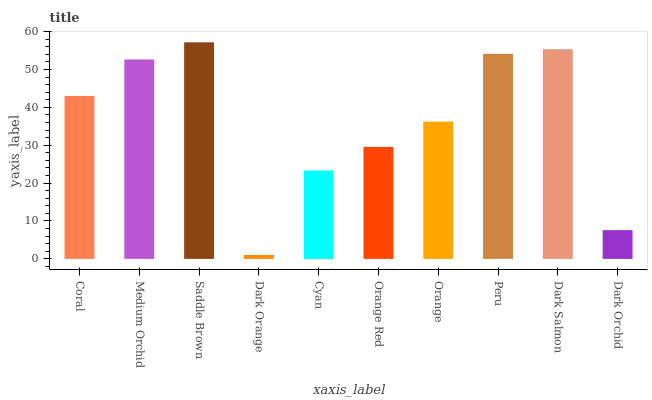Is Dark Orange the minimum?
Answer yes or no. Yes. Is Saddle Brown the maximum?
Answer yes or no. Yes. Is Medium Orchid the minimum?
Answer yes or no. No. Is Medium Orchid the maximum?
Answer yes or no. No. Is Medium Orchid greater than Coral?
Answer yes or no. Yes. Is Coral less than Medium Orchid?
Answer yes or no. Yes. Is Coral greater than Medium Orchid?
Answer yes or no. No. Is Medium Orchid less than Coral?
Answer yes or no. No. Is Coral the high median?
Answer yes or no. Yes. Is Orange the low median?
Answer yes or no. Yes. Is Dark Salmon the high median?
Answer yes or no. No. Is Peru the low median?
Answer yes or no. No. 